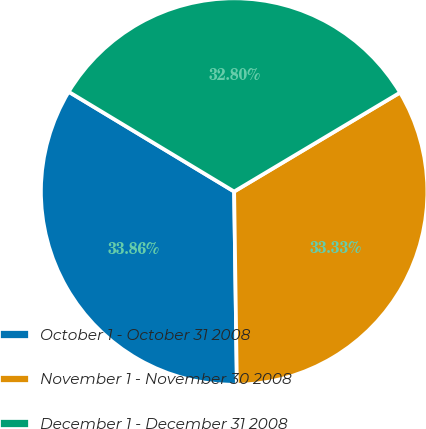Convert chart to OTSL. <chart><loc_0><loc_0><loc_500><loc_500><pie_chart><fcel>October 1 - October 31 2008<fcel>November 1 - November 30 2008<fcel>December 1 - December 31 2008<nl><fcel>33.86%<fcel>33.33%<fcel>32.8%<nl></chart> 